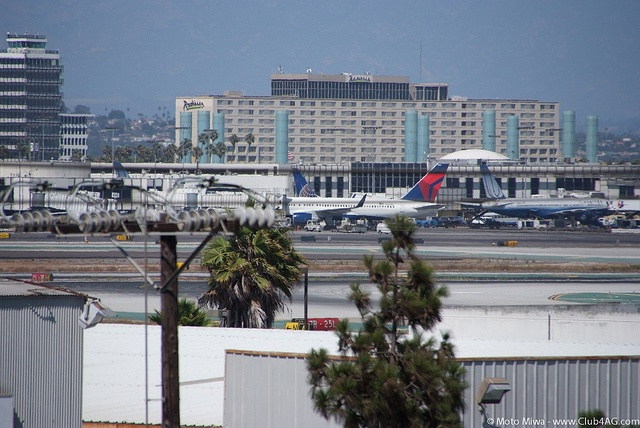Describe the objects in this image and their specific colors. I can see airplane in gray, lightgray, darkgray, and navy tones, airplane in gray, darkgray, and navy tones, airplane in gray, darkblue, and navy tones, car in gray, black, and darkblue tones, and truck in gray, darkgray, and black tones in this image. 